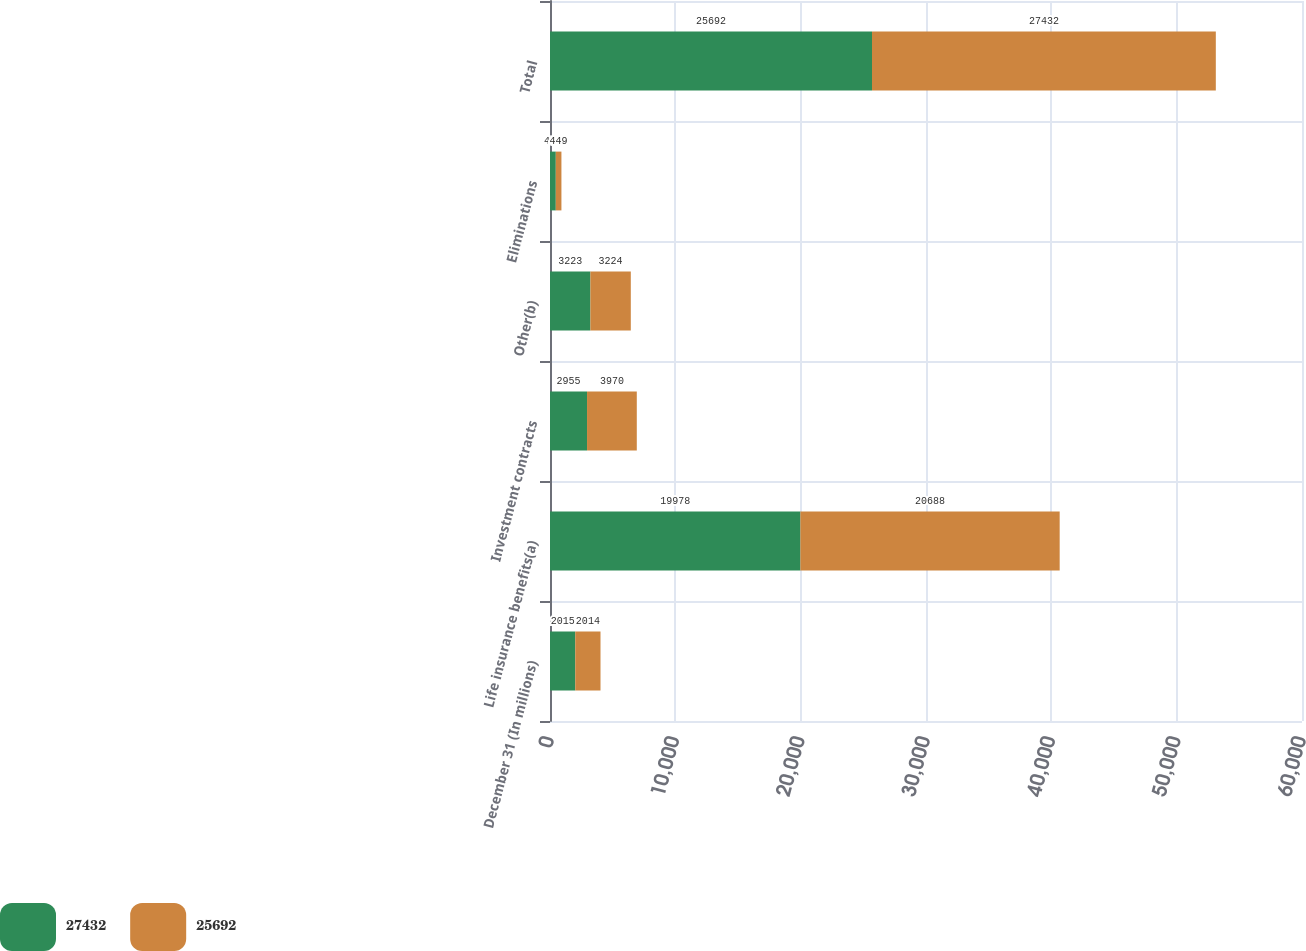<chart> <loc_0><loc_0><loc_500><loc_500><stacked_bar_chart><ecel><fcel>December 31 (In millions)<fcel>Life insurance benefits(a)<fcel>Investment contracts<fcel>Other(b)<fcel>Eliminations<fcel>Total<nl><fcel>27432<fcel>2015<fcel>19978<fcel>2955<fcel>3223<fcel>463<fcel>25692<nl><fcel>25692<fcel>2014<fcel>20688<fcel>3970<fcel>3224<fcel>449<fcel>27432<nl></chart> 